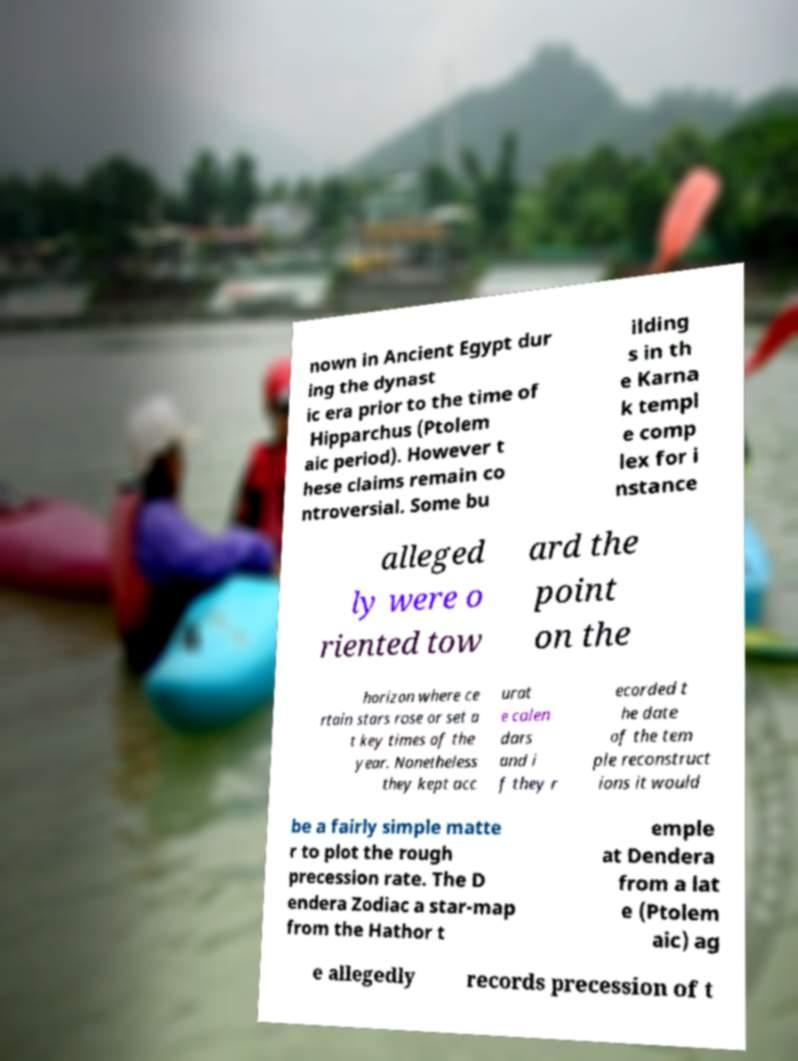There's text embedded in this image that I need extracted. Can you transcribe it verbatim? nown in Ancient Egypt dur ing the dynast ic era prior to the time of Hipparchus (Ptolem aic period). However t hese claims remain co ntroversial. Some bu ilding s in th e Karna k templ e comp lex for i nstance alleged ly were o riented tow ard the point on the horizon where ce rtain stars rose or set a t key times of the year. Nonetheless they kept acc urat e calen dars and i f they r ecorded t he date of the tem ple reconstruct ions it would be a fairly simple matte r to plot the rough precession rate. The D endera Zodiac a star-map from the Hathor t emple at Dendera from a lat e (Ptolem aic) ag e allegedly records precession of t 